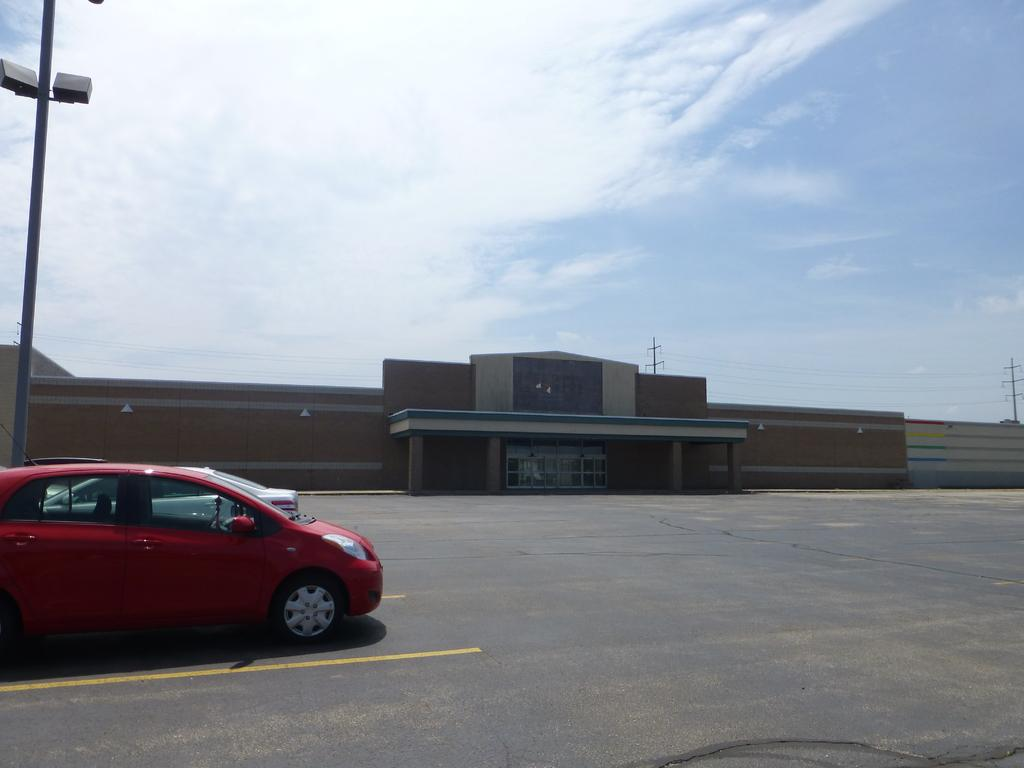What can be seen in the sky in the image? The sky is visible in the image. What type of structure is present in the image? There is a wall and a building in the image. What mode of transportation is parked on the road? There is a red color vehicle parked on the road. What object is visible on the right side of the image? A pole is visible on the right side of the image. How many women are visible in the image? There are no women present in the image. What type of waste is being disposed of in the image? There is no waste visible in the image. 